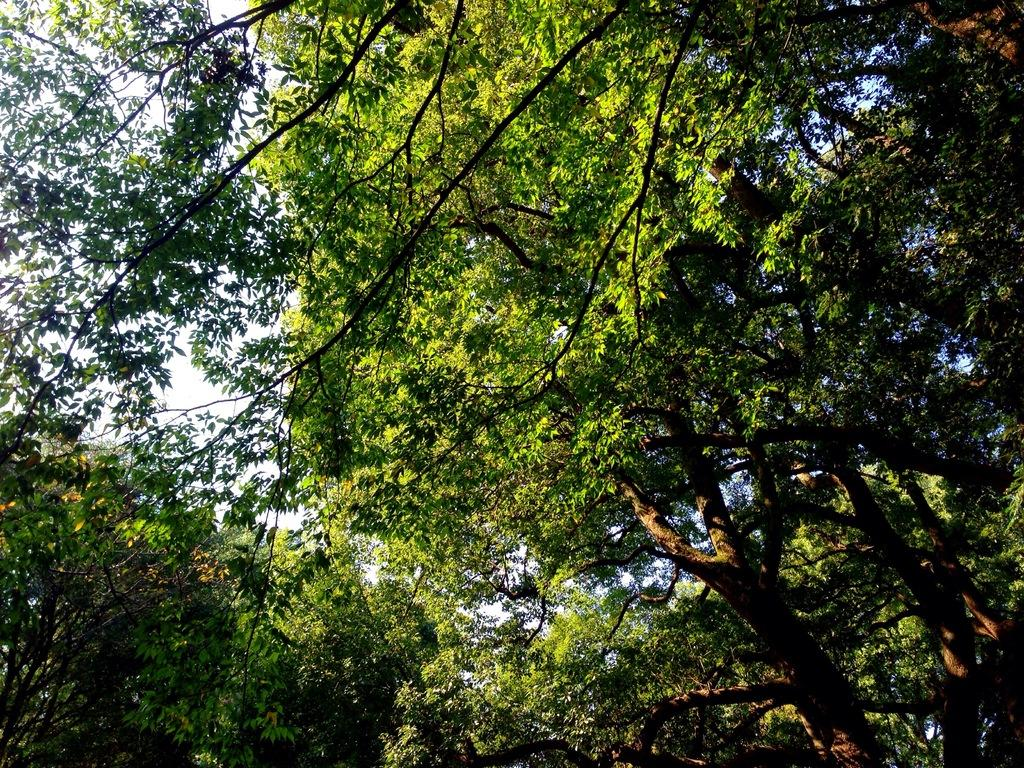What type of vegetation can be seen in the image? There are trees in the image. What part of the natural environment is visible in the image? The sky is visible in the background of the image. What type of comfort can be found in the cellar in the image? There is no cellar present in the image, so it is not possible to determine what type of comfort might be found there. 